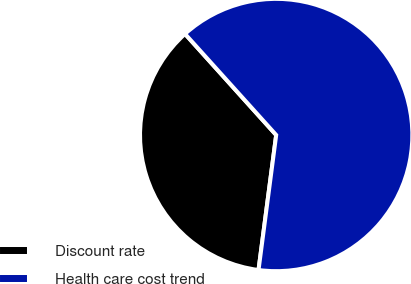Convert chart to OTSL. <chart><loc_0><loc_0><loc_500><loc_500><pie_chart><fcel>Discount rate<fcel>Health care cost trend<nl><fcel>36.25%<fcel>63.75%<nl></chart> 